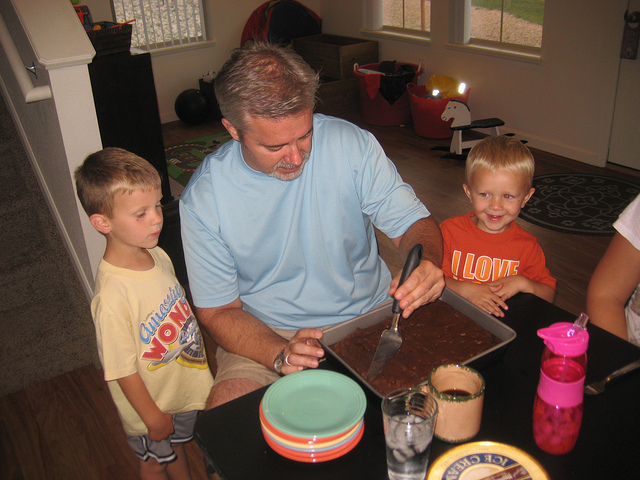Please extract the text content from this image. LOVE WON ICE 